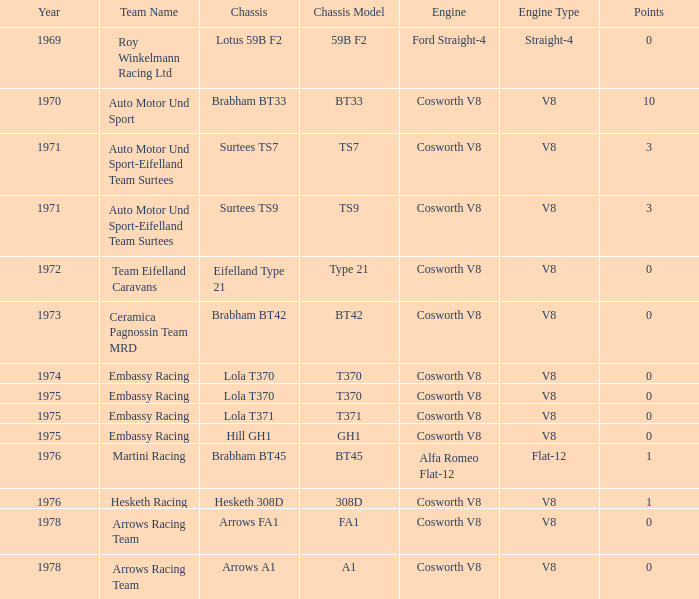In 1970, what entrant had a cosworth v8 engine? Auto Motor Und Sport. 